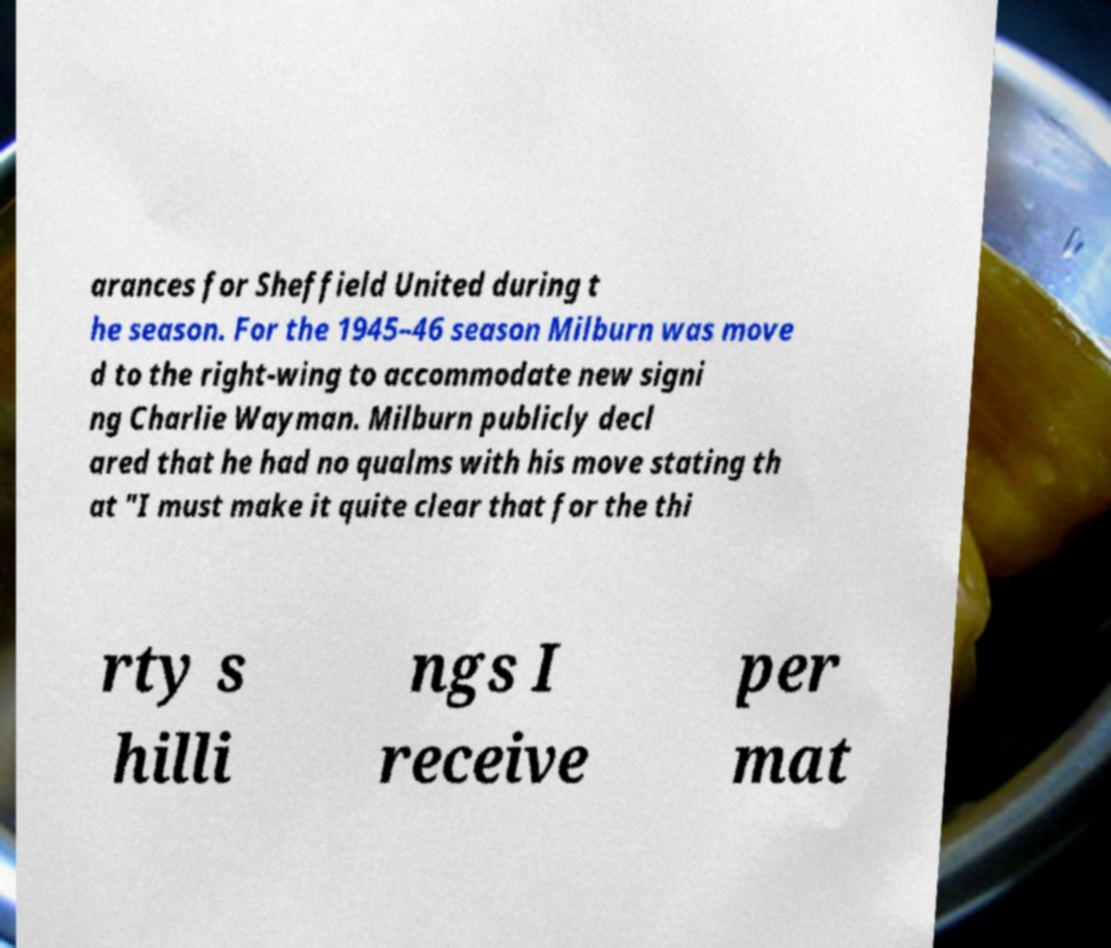Please identify and transcribe the text found in this image. arances for Sheffield United during t he season. For the 1945–46 season Milburn was move d to the right-wing to accommodate new signi ng Charlie Wayman. Milburn publicly decl ared that he had no qualms with his move stating th at "I must make it quite clear that for the thi rty s hilli ngs I receive per mat 